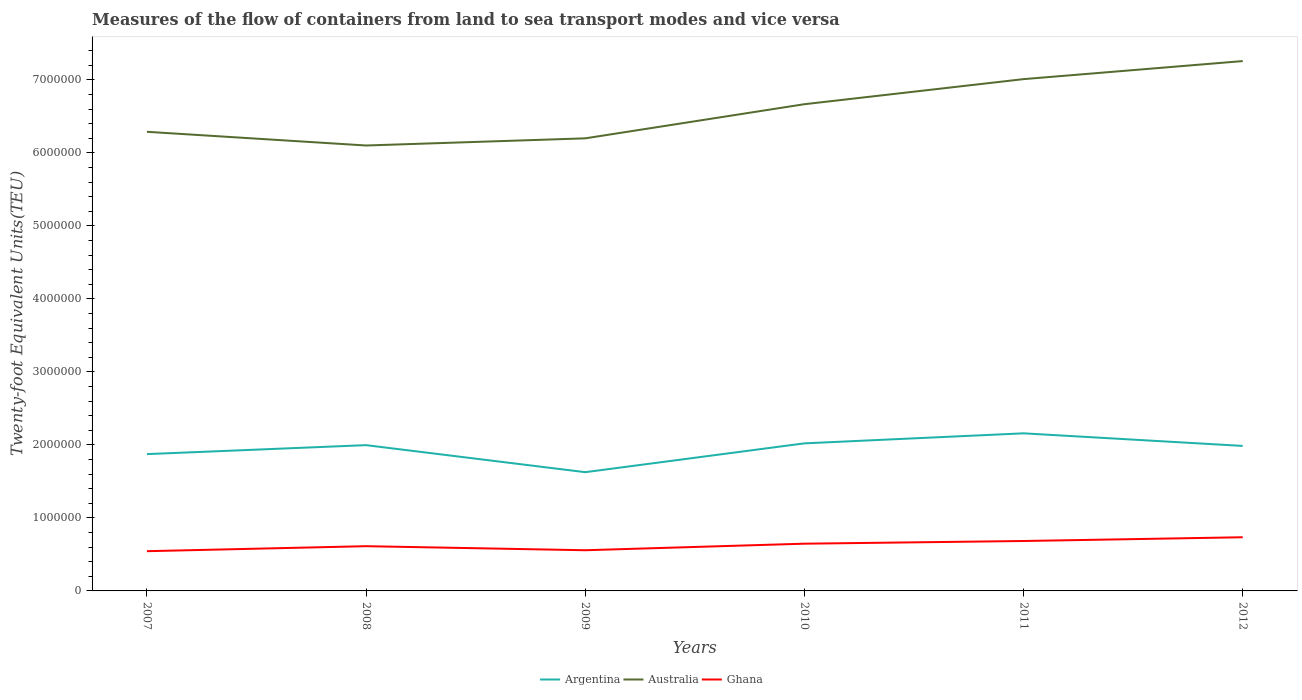How many different coloured lines are there?
Your response must be concise. 3. Across all years, what is the maximum container port traffic in Argentina?
Offer a terse response. 1.63e+06. What is the total container port traffic in Argentina in the graph?
Make the answer very short. 3.52e+04. What is the difference between the highest and the second highest container port traffic in Ghana?
Give a very brief answer. 1.91e+05. What is the difference between the highest and the lowest container port traffic in Argentina?
Ensure brevity in your answer.  4. How many lines are there?
Provide a succinct answer. 3. Are the values on the major ticks of Y-axis written in scientific E-notation?
Make the answer very short. No. Where does the legend appear in the graph?
Ensure brevity in your answer.  Bottom center. How many legend labels are there?
Provide a succinct answer. 3. What is the title of the graph?
Offer a terse response. Measures of the flow of containers from land to sea transport modes and vice versa. What is the label or title of the Y-axis?
Make the answer very short. Twenty-foot Equivalent Units(TEU). What is the Twenty-foot Equivalent Units(TEU) of Argentina in 2007?
Your answer should be very brief. 1.87e+06. What is the Twenty-foot Equivalent Units(TEU) of Australia in 2007?
Make the answer very short. 6.29e+06. What is the Twenty-foot Equivalent Units(TEU) of Ghana in 2007?
Your answer should be very brief. 5.44e+05. What is the Twenty-foot Equivalent Units(TEU) of Argentina in 2008?
Give a very brief answer. 2.00e+06. What is the Twenty-foot Equivalent Units(TEU) of Australia in 2008?
Offer a terse response. 6.10e+06. What is the Twenty-foot Equivalent Units(TEU) of Ghana in 2008?
Your response must be concise. 6.13e+05. What is the Twenty-foot Equivalent Units(TEU) in Argentina in 2009?
Provide a succinct answer. 1.63e+06. What is the Twenty-foot Equivalent Units(TEU) of Australia in 2009?
Offer a very short reply. 6.20e+06. What is the Twenty-foot Equivalent Units(TEU) of Ghana in 2009?
Offer a terse response. 5.57e+05. What is the Twenty-foot Equivalent Units(TEU) in Argentina in 2010?
Your response must be concise. 2.02e+06. What is the Twenty-foot Equivalent Units(TEU) in Australia in 2010?
Your response must be concise. 6.67e+06. What is the Twenty-foot Equivalent Units(TEU) of Ghana in 2010?
Provide a succinct answer. 6.47e+05. What is the Twenty-foot Equivalent Units(TEU) in Argentina in 2011?
Provide a succinct answer. 2.16e+06. What is the Twenty-foot Equivalent Units(TEU) of Australia in 2011?
Keep it short and to the point. 7.01e+06. What is the Twenty-foot Equivalent Units(TEU) of Ghana in 2011?
Your answer should be very brief. 6.84e+05. What is the Twenty-foot Equivalent Units(TEU) in Argentina in 2012?
Provide a succinct answer. 1.99e+06. What is the Twenty-foot Equivalent Units(TEU) in Australia in 2012?
Your answer should be very brief. 7.26e+06. What is the Twenty-foot Equivalent Units(TEU) in Ghana in 2012?
Your answer should be very brief. 7.35e+05. Across all years, what is the maximum Twenty-foot Equivalent Units(TEU) in Argentina?
Keep it short and to the point. 2.16e+06. Across all years, what is the maximum Twenty-foot Equivalent Units(TEU) of Australia?
Offer a very short reply. 7.26e+06. Across all years, what is the maximum Twenty-foot Equivalent Units(TEU) of Ghana?
Offer a terse response. 7.35e+05. Across all years, what is the minimum Twenty-foot Equivalent Units(TEU) in Argentina?
Your answer should be compact. 1.63e+06. Across all years, what is the minimum Twenty-foot Equivalent Units(TEU) of Australia?
Your answer should be compact. 6.10e+06. Across all years, what is the minimum Twenty-foot Equivalent Units(TEU) of Ghana?
Give a very brief answer. 5.44e+05. What is the total Twenty-foot Equivalent Units(TEU) of Argentina in the graph?
Your answer should be very brief. 1.17e+07. What is the total Twenty-foot Equivalent Units(TEU) in Australia in the graph?
Ensure brevity in your answer.  3.95e+07. What is the total Twenty-foot Equivalent Units(TEU) in Ghana in the graph?
Give a very brief answer. 3.78e+06. What is the difference between the Twenty-foot Equivalent Units(TEU) of Argentina in 2007 and that in 2008?
Offer a very short reply. -1.23e+05. What is the difference between the Twenty-foot Equivalent Units(TEU) of Australia in 2007 and that in 2008?
Give a very brief answer. 1.88e+05. What is the difference between the Twenty-foot Equivalent Units(TEU) in Ghana in 2007 and that in 2008?
Ensure brevity in your answer.  -6.86e+04. What is the difference between the Twenty-foot Equivalent Units(TEU) of Argentina in 2007 and that in 2009?
Your response must be concise. 2.47e+05. What is the difference between the Twenty-foot Equivalent Units(TEU) of Australia in 2007 and that in 2009?
Keep it short and to the point. 8.98e+04. What is the difference between the Twenty-foot Equivalent Units(TEU) of Ghana in 2007 and that in 2009?
Your answer should be very brief. -1.30e+04. What is the difference between the Twenty-foot Equivalent Units(TEU) in Argentina in 2007 and that in 2010?
Your response must be concise. -1.47e+05. What is the difference between the Twenty-foot Equivalent Units(TEU) of Australia in 2007 and that in 2010?
Make the answer very short. -3.78e+05. What is the difference between the Twenty-foot Equivalent Units(TEU) in Ghana in 2007 and that in 2010?
Provide a succinct answer. -1.03e+05. What is the difference between the Twenty-foot Equivalent Units(TEU) in Argentina in 2007 and that in 2011?
Offer a very short reply. -2.85e+05. What is the difference between the Twenty-foot Equivalent Units(TEU) of Australia in 2007 and that in 2011?
Offer a terse response. -7.21e+05. What is the difference between the Twenty-foot Equivalent Units(TEU) in Ghana in 2007 and that in 2011?
Give a very brief answer. -1.40e+05. What is the difference between the Twenty-foot Equivalent Units(TEU) of Argentina in 2007 and that in 2012?
Offer a very short reply. -1.12e+05. What is the difference between the Twenty-foot Equivalent Units(TEU) of Australia in 2007 and that in 2012?
Make the answer very short. -9.69e+05. What is the difference between the Twenty-foot Equivalent Units(TEU) of Ghana in 2007 and that in 2012?
Offer a terse response. -1.91e+05. What is the difference between the Twenty-foot Equivalent Units(TEU) in Argentina in 2008 and that in 2009?
Make the answer very short. 3.70e+05. What is the difference between the Twenty-foot Equivalent Units(TEU) in Australia in 2008 and that in 2009?
Ensure brevity in your answer.  -9.80e+04. What is the difference between the Twenty-foot Equivalent Units(TEU) of Ghana in 2008 and that in 2009?
Offer a terse response. 5.55e+04. What is the difference between the Twenty-foot Equivalent Units(TEU) of Argentina in 2008 and that in 2010?
Provide a short and direct response. -2.45e+04. What is the difference between the Twenty-foot Equivalent Units(TEU) of Australia in 2008 and that in 2010?
Your answer should be very brief. -5.66e+05. What is the difference between the Twenty-foot Equivalent Units(TEU) of Ghana in 2008 and that in 2010?
Ensure brevity in your answer.  -3.42e+04. What is the difference between the Twenty-foot Equivalent Units(TEU) in Argentina in 2008 and that in 2011?
Your answer should be very brief. -1.62e+05. What is the difference between the Twenty-foot Equivalent Units(TEU) of Australia in 2008 and that in 2011?
Ensure brevity in your answer.  -9.09e+05. What is the difference between the Twenty-foot Equivalent Units(TEU) in Ghana in 2008 and that in 2011?
Provide a short and direct response. -7.11e+04. What is the difference between the Twenty-foot Equivalent Units(TEU) of Argentina in 2008 and that in 2012?
Offer a terse response. 1.07e+04. What is the difference between the Twenty-foot Equivalent Units(TEU) of Australia in 2008 and that in 2012?
Provide a short and direct response. -1.16e+06. What is the difference between the Twenty-foot Equivalent Units(TEU) of Ghana in 2008 and that in 2012?
Make the answer very short. -1.22e+05. What is the difference between the Twenty-foot Equivalent Units(TEU) in Argentina in 2009 and that in 2010?
Offer a terse response. -3.95e+05. What is the difference between the Twenty-foot Equivalent Units(TEU) in Australia in 2009 and that in 2010?
Offer a terse response. -4.68e+05. What is the difference between the Twenty-foot Equivalent Units(TEU) of Ghana in 2009 and that in 2010?
Ensure brevity in your answer.  -8.97e+04. What is the difference between the Twenty-foot Equivalent Units(TEU) in Argentina in 2009 and that in 2011?
Offer a very short reply. -5.32e+05. What is the difference between the Twenty-foot Equivalent Units(TEU) in Australia in 2009 and that in 2011?
Your answer should be compact. -8.11e+05. What is the difference between the Twenty-foot Equivalent Units(TEU) in Ghana in 2009 and that in 2011?
Make the answer very short. -1.27e+05. What is the difference between the Twenty-foot Equivalent Units(TEU) in Argentina in 2009 and that in 2012?
Make the answer very short. -3.60e+05. What is the difference between the Twenty-foot Equivalent Units(TEU) in Australia in 2009 and that in 2012?
Give a very brief answer. -1.06e+06. What is the difference between the Twenty-foot Equivalent Units(TEU) in Ghana in 2009 and that in 2012?
Keep it short and to the point. -1.78e+05. What is the difference between the Twenty-foot Equivalent Units(TEU) in Argentina in 2010 and that in 2011?
Make the answer very short. -1.37e+05. What is the difference between the Twenty-foot Equivalent Units(TEU) of Australia in 2010 and that in 2011?
Offer a terse response. -3.44e+05. What is the difference between the Twenty-foot Equivalent Units(TEU) of Ghana in 2010 and that in 2011?
Your answer should be very brief. -3.69e+04. What is the difference between the Twenty-foot Equivalent Units(TEU) in Argentina in 2010 and that in 2012?
Provide a short and direct response. 3.52e+04. What is the difference between the Twenty-foot Equivalent Units(TEU) in Australia in 2010 and that in 2012?
Keep it short and to the point. -5.91e+05. What is the difference between the Twenty-foot Equivalent Units(TEU) in Ghana in 2010 and that in 2012?
Give a very brief answer. -8.82e+04. What is the difference between the Twenty-foot Equivalent Units(TEU) in Argentina in 2011 and that in 2012?
Your response must be concise. 1.73e+05. What is the difference between the Twenty-foot Equivalent Units(TEU) of Australia in 2011 and that in 2012?
Offer a terse response. -2.47e+05. What is the difference between the Twenty-foot Equivalent Units(TEU) of Ghana in 2011 and that in 2012?
Offer a terse response. -5.13e+04. What is the difference between the Twenty-foot Equivalent Units(TEU) in Argentina in 2007 and the Twenty-foot Equivalent Units(TEU) in Australia in 2008?
Provide a succinct answer. -4.23e+06. What is the difference between the Twenty-foot Equivalent Units(TEU) in Argentina in 2007 and the Twenty-foot Equivalent Units(TEU) in Ghana in 2008?
Your answer should be compact. 1.26e+06. What is the difference between the Twenty-foot Equivalent Units(TEU) in Australia in 2007 and the Twenty-foot Equivalent Units(TEU) in Ghana in 2008?
Offer a very short reply. 5.68e+06. What is the difference between the Twenty-foot Equivalent Units(TEU) in Argentina in 2007 and the Twenty-foot Equivalent Units(TEU) in Australia in 2009?
Your answer should be very brief. -4.33e+06. What is the difference between the Twenty-foot Equivalent Units(TEU) of Argentina in 2007 and the Twenty-foot Equivalent Units(TEU) of Ghana in 2009?
Offer a terse response. 1.32e+06. What is the difference between the Twenty-foot Equivalent Units(TEU) in Australia in 2007 and the Twenty-foot Equivalent Units(TEU) in Ghana in 2009?
Make the answer very short. 5.73e+06. What is the difference between the Twenty-foot Equivalent Units(TEU) of Argentina in 2007 and the Twenty-foot Equivalent Units(TEU) of Australia in 2010?
Offer a very short reply. -4.79e+06. What is the difference between the Twenty-foot Equivalent Units(TEU) in Argentina in 2007 and the Twenty-foot Equivalent Units(TEU) in Ghana in 2010?
Offer a very short reply. 1.23e+06. What is the difference between the Twenty-foot Equivalent Units(TEU) in Australia in 2007 and the Twenty-foot Equivalent Units(TEU) in Ghana in 2010?
Your response must be concise. 5.64e+06. What is the difference between the Twenty-foot Equivalent Units(TEU) in Argentina in 2007 and the Twenty-foot Equivalent Units(TEU) in Australia in 2011?
Make the answer very short. -5.14e+06. What is the difference between the Twenty-foot Equivalent Units(TEU) in Argentina in 2007 and the Twenty-foot Equivalent Units(TEU) in Ghana in 2011?
Make the answer very short. 1.19e+06. What is the difference between the Twenty-foot Equivalent Units(TEU) in Australia in 2007 and the Twenty-foot Equivalent Units(TEU) in Ghana in 2011?
Offer a terse response. 5.61e+06. What is the difference between the Twenty-foot Equivalent Units(TEU) of Argentina in 2007 and the Twenty-foot Equivalent Units(TEU) of Australia in 2012?
Make the answer very short. -5.38e+06. What is the difference between the Twenty-foot Equivalent Units(TEU) in Argentina in 2007 and the Twenty-foot Equivalent Units(TEU) in Ghana in 2012?
Ensure brevity in your answer.  1.14e+06. What is the difference between the Twenty-foot Equivalent Units(TEU) of Australia in 2007 and the Twenty-foot Equivalent Units(TEU) of Ghana in 2012?
Make the answer very short. 5.55e+06. What is the difference between the Twenty-foot Equivalent Units(TEU) of Argentina in 2008 and the Twenty-foot Equivalent Units(TEU) of Australia in 2009?
Provide a short and direct response. -4.20e+06. What is the difference between the Twenty-foot Equivalent Units(TEU) in Argentina in 2008 and the Twenty-foot Equivalent Units(TEU) in Ghana in 2009?
Your answer should be very brief. 1.44e+06. What is the difference between the Twenty-foot Equivalent Units(TEU) in Australia in 2008 and the Twenty-foot Equivalent Units(TEU) in Ghana in 2009?
Ensure brevity in your answer.  5.55e+06. What is the difference between the Twenty-foot Equivalent Units(TEU) of Argentina in 2008 and the Twenty-foot Equivalent Units(TEU) of Australia in 2010?
Offer a very short reply. -4.67e+06. What is the difference between the Twenty-foot Equivalent Units(TEU) of Argentina in 2008 and the Twenty-foot Equivalent Units(TEU) of Ghana in 2010?
Provide a short and direct response. 1.35e+06. What is the difference between the Twenty-foot Equivalent Units(TEU) of Australia in 2008 and the Twenty-foot Equivalent Units(TEU) of Ghana in 2010?
Ensure brevity in your answer.  5.46e+06. What is the difference between the Twenty-foot Equivalent Units(TEU) in Argentina in 2008 and the Twenty-foot Equivalent Units(TEU) in Australia in 2011?
Provide a short and direct response. -5.01e+06. What is the difference between the Twenty-foot Equivalent Units(TEU) of Argentina in 2008 and the Twenty-foot Equivalent Units(TEU) of Ghana in 2011?
Your answer should be compact. 1.31e+06. What is the difference between the Twenty-foot Equivalent Units(TEU) of Australia in 2008 and the Twenty-foot Equivalent Units(TEU) of Ghana in 2011?
Offer a very short reply. 5.42e+06. What is the difference between the Twenty-foot Equivalent Units(TEU) in Argentina in 2008 and the Twenty-foot Equivalent Units(TEU) in Australia in 2012?
Your answer should be very brief. -5.26e+06. What is the difference between the Twenty-foot Equivalent Units(TEU) of Argentina in 2008 and the Twenty-foot Equivalent Units(TEU) of Ghana in 2012?
Make the answer very short. 1.26e+06. What is the difference between the Twenty-foot Equivalent Units(TEU) of Australia in 2008 and the Twenty-foot Equivalent Units(TEU) of Ghana in 2012?
Your answer should be very brief. 5.37e+06. What is the difference between the Twenty-foot Equivalent Units(TEU) of Argentina in 2009 and the Twenty-foot Equivalent Units(TEU) of Australia in 2010?
Make the answer very short. -5.04e+06. What is the difference between the Twenty-foot Equivalent Units(TEU) in Argentina in 2009 and the Twenty-foot Equivalent Units(TEU) in Ghana in 2010?
Ensure brevity in your answer.  9.80e+05. What is the difference between the Twenty-foot Equivalent Units(TEU) of Australia in 2009 and the Twenty-foot Equivalent Units(TEU) of Ghana in 2010?
Your answer should be compact. 5.55e+06. What is the difference between the Twenty-foot Equivalent Units(TEU) in Argentina in 2009 and the Twenty-foot Equivalent Units(TEU) in Australia in 2011?
Your answer should be very brief. -5.38e+06. What is the difference between the Twenty-foot Equivalent Units(TEU) in Argentina in 2009 and the Twenty-foot Equivalent Units(TEU) in Ghana in 2011?
Offer a terse response. 9.43e+05. What is the difference between the Twenty-foot Equivalent Units(TEU) in Australia in 2009 and the Twenty-foot Equivalent Units(TEU) in Ghana in 2011?
Offer a very short reply. 5.52e+06. What is the difference between the Twenty-foot Equivalent Units(TEU) of Argentina in 2009 and the Twenty-foot Equivalent Units(TEU) of Australia in 2012?
Offer a very short reply. -5.63e+06. What is the difference between the Twenty-foot Equivalent Units(TEU) of Argentina in 2009 and the Twenty-foot Equivalent Units(TEU) of Ghana in 2012?
Give a very brief answer. 8.92e+05. What is the difference between the Twenty-foot Equivalent Units(TEU) of Australia in 2009 and the Twenty-foot Equivalent Units(TEU) of Ghana in 2012?
Ensure brevity in your answer.  5.47e+06. What is the difference between the Twenty-foot Equivalent Units(TEU) of Argentina in 2010 and the Twenty-foot Equivalent Units(TEU) of Australia in 2011?
Make the answer very short. -4.99e+06. What is the difference between the Twenty-foot Equivalent Units(TEU) in Argentina in 2010 and the Twenty-foot Equivalent Units(TEU) in Ghana in 2011?
Your answer should be very brief. 1.34e+06. What is the difference between the Twenty-foot Equivalent Units(TEU) of Australia in 2010 and the Twenty-foot Equivalent Units(TEU) of Ghana in 2011?
Your response must be concise. 5.98e+06. What is the difference between the Twenty-foot Equivalent Units(TEU) in Argentina in 2010 and the Twenty-foot Equivalent Units(TEU) in Australia in 2012?
Provide a succinct answer. -5.24e+06. What is the difference between the Twenty-foot Equivalent Units(TEU) in Argentina in 2010 and the Twenty-foot Equivalent Units(TEU) in Ghana in 2012?
Offer a very short reply. 1.29e+06. What is the difference between the Twenty-foot Equivalent Units(TEU) of Australia in 2010 and the Twenty-foot Equivalent Units(TEU) of Ghana in 2012?
Keep it short and to the point. 5.93e+06. What is the difference between the Twenty-foot Equivalent Units(TEU) of Argentina in 2011 and the Twenty-foot Equivalent Units(TEU) of Australia in 2012?
Provide a short and direct response. -5.10e+06. What is the difference between the Twenty-foot Equivalent Units(TEU) of Argentina in 2011 and the Twenty-foot Equivalent Units(TEU) of Ghana in 2012?
Your answer should be very brief. 1.42e+06. What is the difference between the Twenty-foot Equivalent Units(TEU) of Australia in 2011 and the Twenty-foot Equivalent Units(TEU) of Ghana in 2012?
Your answer should be compact. 6.28e+06. What is the average Twenty-foot Equivalent Units(TEU) in Argentina per year?
Your answer should be compact. 1.94e+06. What is the average Twenty-foot Equivalent Units(TEU) of Australia per year?
Offer a very short reply. 6.59e+06. What is the average Twenty-foot Equivalent Units(TEU) of Ghana per year?
Your answer should be compact. 6.30e+05. In the year 2007, what is the difference between the Twenty-foot Equivalent Units(TEU) of Argentina and Twenty-foot Equivalent Units(TEU) of Australia?
Your answer should be very brief. -4.42e+06. In the year 2007, what is the difference between the Twenty-foot Equivalent Units(TEU) in Argentina and Twenty-foot Equivalent Units(TEU) in Ghana?
Your answer should be very brief. 1.33e+06. In the year 2007, what is the difference between the Twenty-foot Equivalent Units(TEU) of Australia and Twenty-foot Equivalent Units(TEU) of Ghana?
Your response must be concise. 5.75e+06. In the year 2008, what is the difference between the Twenty-foot Equivalent Units(TEU) of Argentina and Twenty-foot Equivalent Units(TEU) of Australia?
Ensure brevity in your answer.  -4.11e+06. In the year 2008, what is the difference between the Twenty-foot Equivalent Units(TEU) in Argentina and Twenty-foot Equivalent Units(TEU) in Ghana?
Offer a terse response. 1.38e+06. In the year 2008, what is the difference between the Twenty-foot Equivalent Units(TEU) in Australia and Twenty-foot Equivalent Units(TEU) in Ghana?
Keep it short and to the point. 5.49e+06. In the year 2009, what is the difference between the Twenty-foot Equivalent Units(TEU) in Argentina and Twenty-foot Equivalent Units(TEU) in Australia?
Offer a very short reply. -4.57e+06. In the year 2009, what is the difference between the Twenty-foot Equivalent Units(TEU) in Argentina and Twenty-foot Equivalent Units(TEU) in Ghana?
Provide a short and direct response. 1.07e+06. In the year 2009, what is the difference between the Twenty-foot Equivalent Units(TEU) in Australia and Twenty-foot Equivalent Units(TEU) in Ghana?
Your answer should be compact. 5.64e+06. In the year 2010, what is the difference between the Twenty-foot Equivalent Units(TEU) of Argentina and Twenty-foot Equivalent Units(TEU) of Australia?
Ensure brevity in your answer.  -4.65e+06. In the year 2010, what is the difference between the Twenty-foot Equivalent Units(TEU) of Argentina and Twenty-foot Equivalent Units(TEU) of Ghana?
Make the answer very short. 1.37e+06. In the year 2010, what is the difference between the Twenty-foot Equivalent Units(TEU) in Australia and Twenty-foot Equivalent Units(TEU) in Ghana?
Your answer should be very brief. 6.02e+06. In the year 2011, what is the difference between the Twenty-foot Equivalent Units(TEU) of Argentina and Twenty-foot Equivalent Units(TEU) of Australia?
Your answer should be very brief. -4.85e+06. In the year 2011, what is the difference between the Twenty-foot Equivalent Units(TEU) in Argentina and Twenty-foot Equivalent Units(TEU) in Ghana?
Ensure brevity in your answer.  1.48e+06. In the year 2011, what is the difference between the Twenty-foot Equivalent Units(TEU) in Australia and Twenty-foot Equivalent Units(TEU) in Ghana?
Ensure brevity in your answer.  6.33e+06. In the year 2012, what is the difference between the Twenty-foot Equivalent Units(TEU) in Argentina and Twenty-foot Equivalent Units(TEU) in Australia?
Keep it short and to the point. -5.27e+06. In the year 2012, what is the difference between the Twenty-foot Equivalent Units(TEU) of Argentina and Twenty-foot Equivalent Units(TEU) of Ghana?
Offer a terse response. 1.25e+06. In the year 2012, what is the difference between the Twenty-foot Equivalent Units(TEU) of Australia and Twenty-foot Equivalent Units(TEU) of Ghana?
Your answer should be very brief. 6.52e+06. What is the ratio of the Twenty-foot Equivalent Units(TEU) in Argentina in 2007 to that in 2008?
Offer a terse response. 0.94. What is the ratio of the Twenty-foot Equivalent Units(TEU) in Australia in 2007 to that in 2008?
Your response must be concise. 1.03. What is the ratio of the Twenty-foot Equivalent Units(TEU) of Ghana in 2007 to that in 2008?
Your answer should be very brief. 0.89. What is the ratio of the Twenty-foot Equivalent Units(TEU) of Argentina in 2007 to that in 2009?
Your answer should be compact. 1.15. What is the ratio of the Twenty-foot Equivalent Units(TEU) of Australia in 2007 to that in 2009?
Keep it short and to the point. 1.01. What is the ratio of the Twenty-foot Equivalent Units(TEU) of Ghana in 2007 to that in 2009?
Keep it short and to the point. 0.98. What is the ratio of the Twenty-foot Equivalent Units(TEU) in Argentina in 2007 to that in 2010?
Your answer should be very brief. 0.93. What is the ratio of the Twenty-foot Equivalent Units(TEU) in Australia in 2007 to that in 2010?
Provide a succinct answer. 0.94. What is the ratio of the Twenty-foot Equivalent Units(TEU) of Ghana in 2007 to that in 2010?
Give a very brief answer. 0.84. What is the ratio of the Twenty-foot Equivalent Units(TEU) in Argentina in 2007 to that in 2011?
Your answer should be very brief. 0.87. What is the ratio of the Twenty-foot Equivalent Units(TEU) in Australia in 2007 to that in 2011?
Keep it short and to the point. 0.9. What is the ratio of the Twenty-foot Equivalent Units(TEU) in Ghana in 2007 to that in 2011?
Offer a very short reply. 0.8. What is the ratio of the Twenty-foot Equivalent Units(TEU) in Argentina in 2007 to that in 2012?
Your answer should be compact. 0.94. What is the ratio of the Twenty-foot Equivalent Units(TEU) in Australia in 2007 to that in 2012?
Give a very brief answer. 0.87. What is the ratio of the Twenty-foot Equivalent Units(TEU) of Ghana in 2007 to that in 2012?
Offer a very short reply. 0.74. What is the ratio of the Twenty-foot Equivalent Units(TEU) in Argentina in 2008 to that in 2009?
Your answer should be very brief. 1.23. What is the ratio of the Twenty-foot Equivalent Units(TEU) of Australia in 2008 to that in 2009?
Give a very brief answer. 0.98. What is the ratio of the Twenty-foot Equivalent Units(TEU) in Ghana in 2008 to that in 2009?
Give a very brief answer. 1.1. What is the ratio of the Twenty-foot Equivalent Units(TEU) in Argentina in 2008 to that in 2010?
Make the answer very short. 0.99. What is the ratio of the Twenty-foot Equivalent Units(TEU) in Australia in 2008 to that in 2010?
Your response must be concise. 0.92. What is the ratio of the Twenty-foot Equivalent Units(TEU) of Ghana in 2008 to that in 2010?
Your answer should be very brief. 0.95. What is the ratio of the Twenty-foot Equivalent Units(TEU) in Argentina in 2008 to that in 2011?
Offer a terse response. 0.93. What is the ratio of the Twenty-foot Equivalent Units(TEU) of Australia in 2008 to that in 2011?
Offer a terse response. 0.87. What is the ratio of the Twenty-foot Equivalent Units(TEU) of Ghana in 2008 to that in 2011?
Offer a very short reply. 0.9. What is the ratio of the Twenty-foot Equivalent Units(TEU) of Argentina in 2008 to that in 2012?
Your answer should be compact. 1.01. What is the ratio of the Twenty-foot Equivalent Units(TEU) in Australia in 2008 to that in 2012?
Ensure brevity in your answer.  0.84. What is the ratio of the Twenty-foot Equivalent Units(TEU) in Ghana in 2008 to that in 2012?
Your answer should be compact. 0.83. What is the ratio of the Twenty-foot Equivalent Units(TEU) in Argentina in 2009 to that in 2010?
Provide a short and direct response. 0.8. What is the ratio of the Twenty-foot Equivalent Units(TEU) of Australia in 2009 to that in 2010?
Offer a very short reply. 0.93. What is the ratio of the Twenty-foot Equivalent Units(TEU) in Ghana in 2009 to that in 2010?
Offer a terse response. 0.86. What is the ratio of the Twenty-foot Equivalent Units(TEU) of Argentina in 2009 to that in 2011?
Provide a succinct answer. 0.75. What is the ratio of the Twenty-foot Equivalent Units(TEU) in Australia in 2009 to that in 2011?
Give a very brief answer. 0.88. What is the ratio of the Twenty-foot Equivalent Units(TEU) of Ghana in 2009 to that in 2011?
Provide a succinct answer. 0.81. What is the ratio of the Twenty-foot Equivalent Units(TEU) in Argentina in 2009 to that in 2012?
Give a very brief answer. 0.82. What is the ratio of the Twenty-foot Equivalent Units(TEU) of Australia in 2009 to that in 2012?
Make the answer very short. 0.85. What is the ratio of the Twenty-foot Equivalent Units(TEU) in Ghana in 2009 to that in 2012?
Ensure brevity in your answer.  0.76. What is the ratio of the Twenty-foot Equivalent Units(TEU) of Argentina in 2010 to that in 2011?
Your response must be concise. 0.94. What is the ratio of the Twenty-foot Equivalent Units(TEU) in Australia in 2010 to that in 2011?
Your response must be concise. 0.95. What is the ratio of the Twenty-foot Equivalent Units(TEU) in Ghana in 2010 to that in 2011?
Offer a terse response. 0.95. What is the ratio of the Twenty-foot Equivalent Units(TEU) in Argentina in 2010 to that in 2012?
Your answer should be very brief. 1.02. What is the ratio of the Twenty-foot Equivalent Units(TEU) in Australia in 2010 to that in 2012?
Your answer should be compact. 0.92. What is the ratio of the Twenty-foot Equivalent Units(TEU) in Ghana in 2010 to that in 2012?
Offer a very short reply. 0.88. What is the ratio of the Twenty-foot Equivalent Units(TEU) in Argentina in 2011 to that in 2012?
Your response must be concise. 1.09. What is the ratio of the Twenty-foot Equivalent Units(TEU) of Australia in 2011 to that in 2012?
Provide a succinct answer. 0.97. What is the ratio of the Twenty-foot Equivalent Units(TEU) of Ghana in 2011 to that in 2012?
Ensure brevity in your answer.  0.93. What is the difference between the highest and the second highest Twenty-foot Equivalent Units(TEU) of Argentina?
Provide a short and direct response. 1.37e+05. What is the difference between the highest and the second highest Twenty-foot Equivalent Units(TEU) of Australia?
Your answer should be very brief. 2.47e+05. What is the difference between the highest and the second highest Twenty-foot Equivalent Units(TEU) of Ghana?
Keep it short and to the point. 5.13e+04. What is the difference between the highest and the lowest Twenty-foot Equivalent Units(TEU) of Argentina?
Make the answer very short. 5.32e+05. What is the difference between the highest and the lowest Twenty-foot Equivalent Units(TEU) in Australia?
Offer a very short reply. 1.16e+06. What is the difference between the highest and the lowest Twenty-foot Equivalent Units(TEU) in Ghana?
Give a very brief answer. 1.91e+05. 